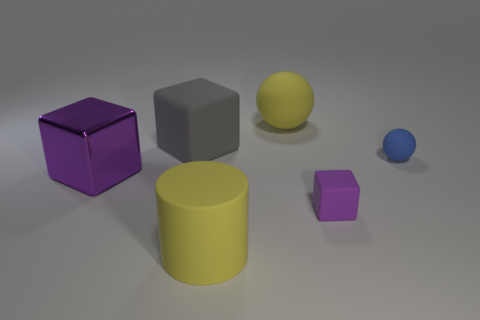Add 3 matte blocks. How many objects exist? 9 Subtract all tiny cubes. How many cubes are left? 2 Subtract all yellow spheres. How many spheres are left? 1 Subtract 0 brown balls. How many objects are left? 6 Subtract all balls. How many objects are left? 4 Subtract 1 balls. How many balls are left? 1 Subtract all gray cubes. Subtract all blue spheres. How many cubes are left? 2 Subtract all cyan cylinders. How many blue spheres are left? 1 Subtract all purple cylinders. Subtract all large cylinders. How many objects are left? 5 Add 2 metal blocks. How many metal blocks are left? 3 